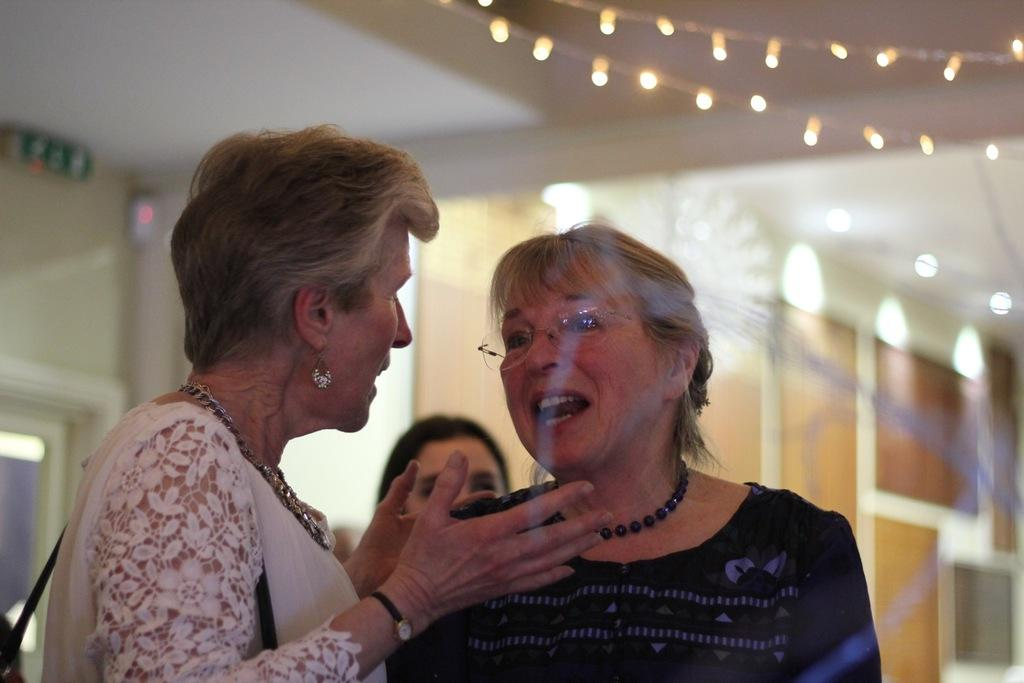What is happening in the foreground of the image? There are two women standing and talking to each other in the foreground. Are there any other people in the image? Yes, there is another woman behind them. Can you describe the background of the image? The background is blurred, and there are lights visible in it. What type of letter is the woman holding in the image? There is no woman holding a letter in the image. What season is it in the image, considering the presence of a slip? There is no mention of a slip or any season-specific clothing in the image. 